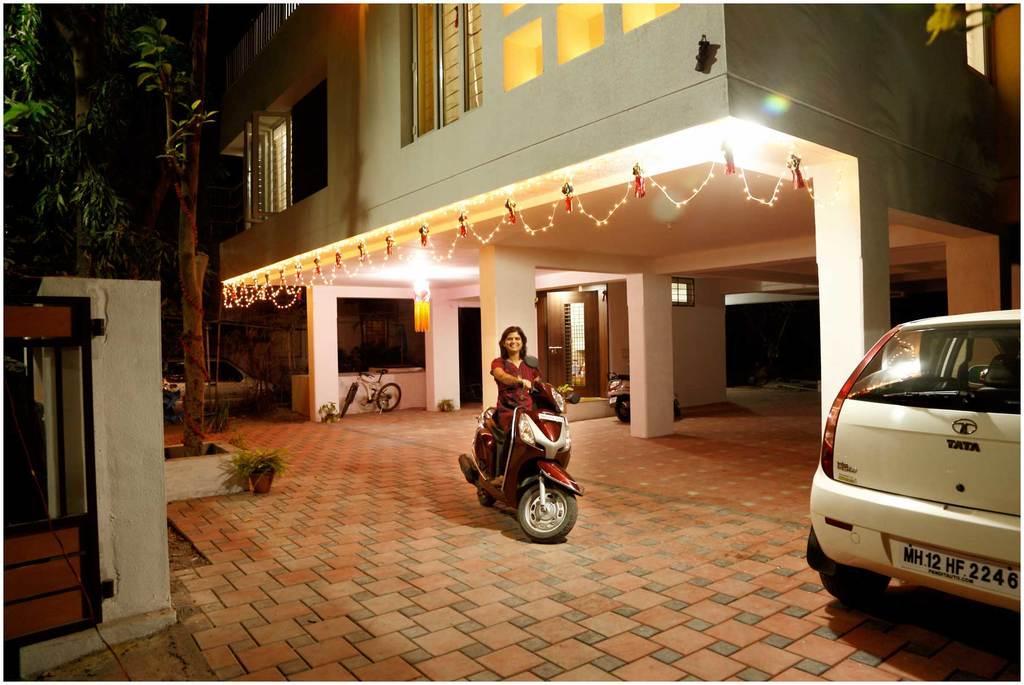Describe this image in one or two sentences. In this image I can see the person sitting on the vehicle. In front the vehicle is in white color, background I can see the building in cream color and I can also see few windows, lights and I can see the gate in brown color and few trees in green color. 